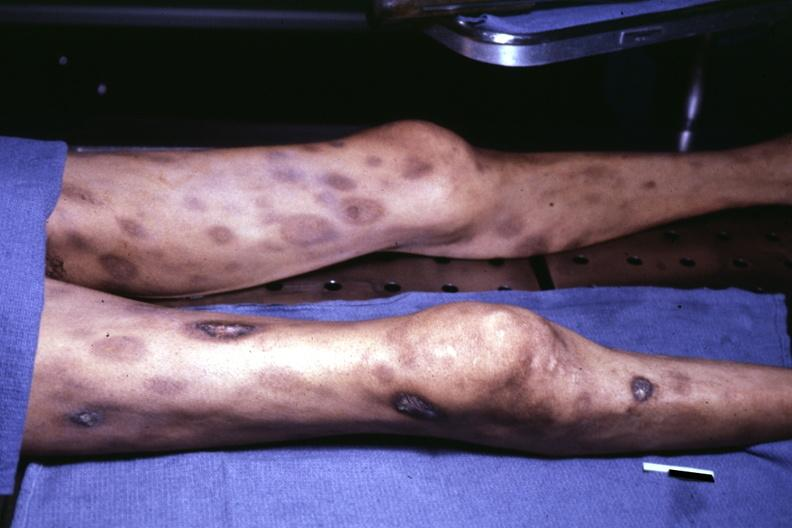does hearts ecchymose with central necrosis?
Answer the question using a single word or phrase. No 